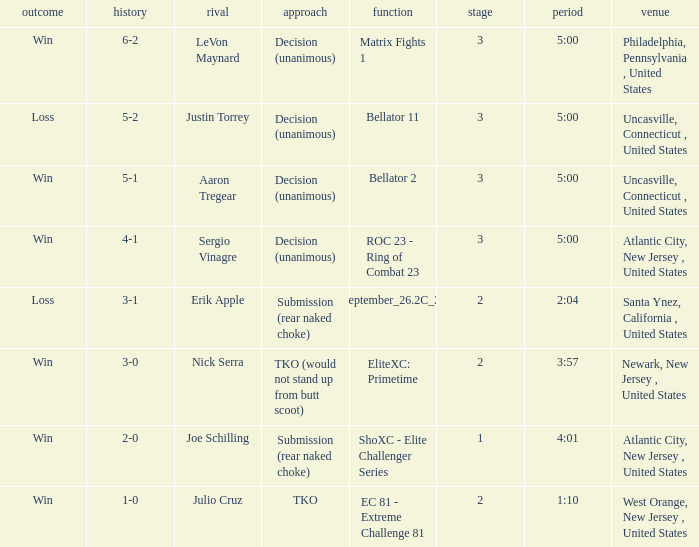What round was it when the method was TKO (would not stand up from Butt Scoot)? 2.0. 